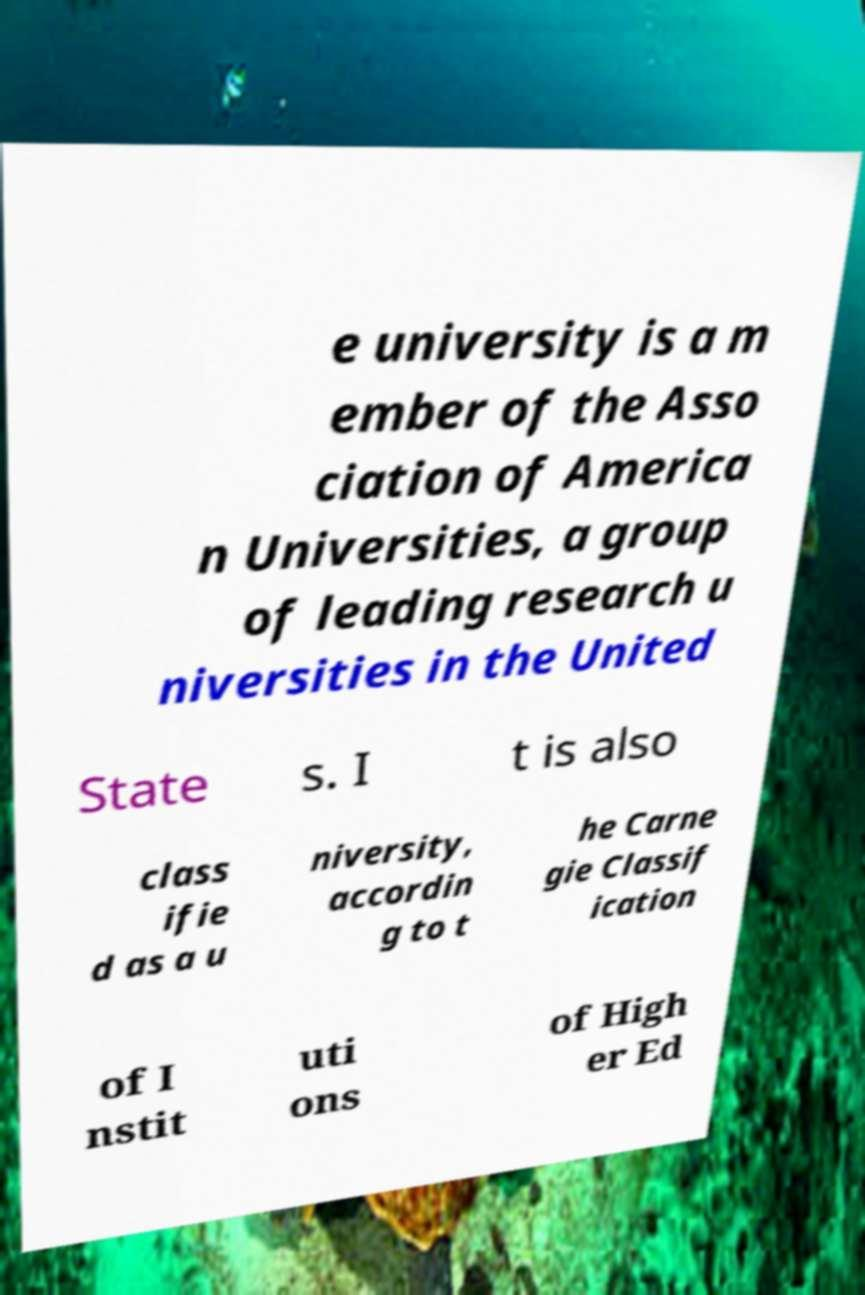There's text embedded in this image that I need extracted. Can you transcribe it verbatim? e university is a m ember of the Asso ciation of America n Universities, a group of leading research u niversities in the United State s. I t is also class ifie d as a u niversity, accordin g to t he Carne gie Classif ication of I nstit uti ons of High er Ed 